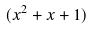<formula> <loc_0><loc_0><loc_500><loc_500>( x ^ { 2 } + x + 1 )</formula> 